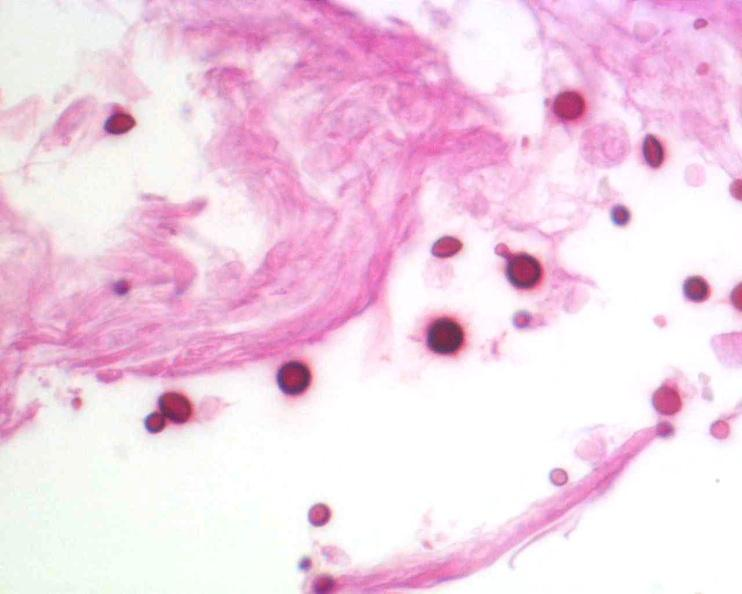what stain?
Answer the question using a single word or phrase. Brain 